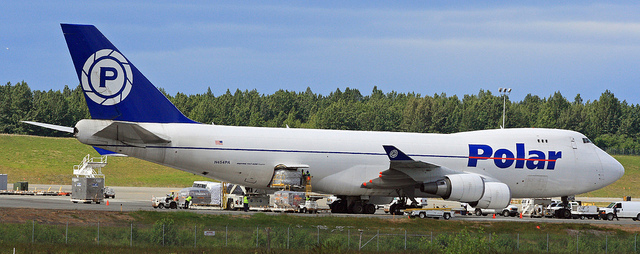Read and extract the text from this image. Polar P 